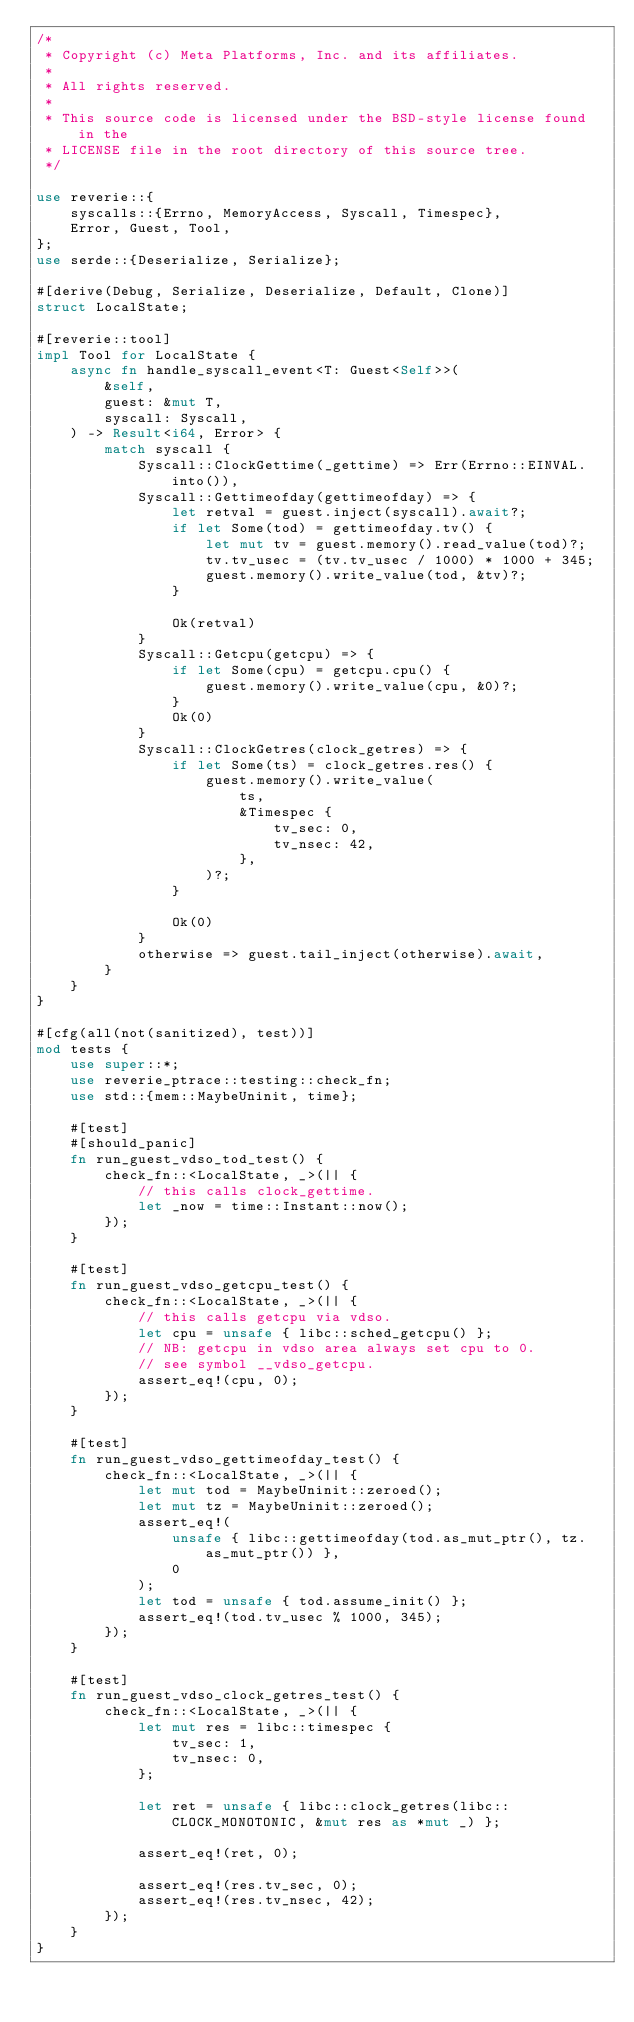<code> <loc_0><loc_0><loc_500><loc_500><_Rust_>/*
 * Copyright (c) Meta Platforms, Inc. and its affiliates.
 *
 * All rights reserved.
 *
 * This source code is licensed under the BSD-style license found in the
 * LICENSE file in the root directory of this source tree.
 */

use reverie::{
    syscalls::{Errno, MemoryAccess, Syscall, Timespec},
    Error, Guest, Tool,
};
use serde::{Deserialize, Serialize};

#[derive(Debug, Serialize, Deserialize, Default, Clone)]
struct LocalState;

#[reverie::tool]
impl Tool for LocalState {
    async fn handle_syscall_event<T: Guest<Self>>(
        &self,
        guest: &mut T,
        syscall: Syscall,
    ) -> Result<i64, Error> {
        match syscall {
            Syscall::ClockGettime(_gettime) => Err(Errno::EINVAL.into()),
            Syscall::Gettimeofday(gettimeofday) => {
                let retval = guest.inject(syscall).await?;
                if let Some(tod) = gettimeofday.tv() {
                    let mut tv = guest.memory().read_value(tod)?;
                    tv.tv_usec = (tv.tv_usec / 1000) * 1000 + 345;
                    guest.memory().write_value(tod, &tv)?;
                }

                Ok(retval)
            }
            Syscall::Getcpu(getcpu) => {
                if let Some(cpu) = getcpu.cpu() {
                    guest.memory().write_value(cpu, &0)?;
                }
                Ok(0)
            }
            Syscall::ClockGetres(clock_getres) => {
                if let Some(ts) = clock_getres.res() {
                    guest.memory().write_value(
                        ts,
                        &Timespec {
                            tv_sec: 0,
                            tv_nsec: 42,
                        },
                    )?;
                }

                Ok(0)
            }
            otherwise => guest.tail_inject(otherwise).await,
        }
    }
}

#[cfg(all(not(sanitized), test))]
mod tests {
    use super::*;
    use reverie_ptrace::testing::check_fn;
    use std::{mem::MaybeUninit, time};

    #[test]
    #[should_panic]
    fn run_guest_vdso_tod_test() {
        check_fn::<LocalState, _>(|| {
            // this calls clock_gettime.
            let _now = time::Instant::now();
        });
    }

    #[test]
    fn run_guest_vdso_getcpu_test() {
        check_fn::<LocalState, _>(|| {
            // this calls getcpu via vdso.
            let cpu = unsafe { libc::sched_getcpu() };
            // NB: getcpu in vdso area always set cpu to 0.
            // see symbol __vdso_getcpu.
            assert_eq!(cpu, 0);
        });
    }

    #[test]
    fn run_guest_vdso_gettimeofday_test() {
        check_fn::<LocalState, _>(|| {
            let mut tod = MaybeUninit::zeroed();
            let mut tz = MaybeUninit::zeroed();
            assert_eq!(
                unsafe { libc::gettimeofday(tod.as_mut_ptr(), tz.as_mut_ptr()) },
                0
            );
            let tod = unsafe { tod.assume_init() };
            assert_eq!(tod.tv_usec % 1000, 345);
        });
    }

    #[test]
    fn run_guest_vdso_clock_getres_test() {
        check_fn::<LocalState, _>(|| {
            let mut res = libc::timespec {
                tv_sec: 1,
                tv_nsec: 0,
            };

            let ret = unsafe { libc::clock_getres(libc::CLOCK_MONOTONIC, &mut res as *mut _) };

            assert_eq!(ret, 0);

            assert_eq!(res.tv_sec, 0);
            assert_eq!(res.tv_nsec, 42);
        });
    }
}
</code> 